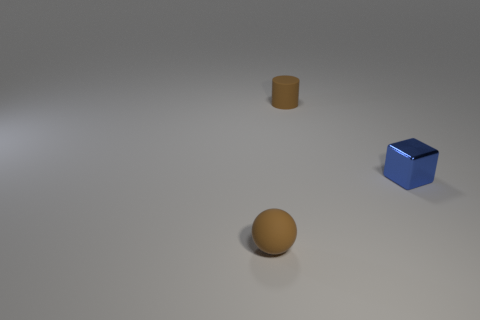Add 1 large brown shiny blocks. How many objects exist? 4 Subtract all blocks. How many objects are left? 2 Add 3 brown matte balls. How many brown matte balls exist? 4 Subtract 0 yellow blocks. How many objects are left? 3 Subtract all spheres. Subtract all tiny brown matte spheres. How many objects are left? 1 Add 3 tiny matte balls. How many tiny matte balls are left? 4 